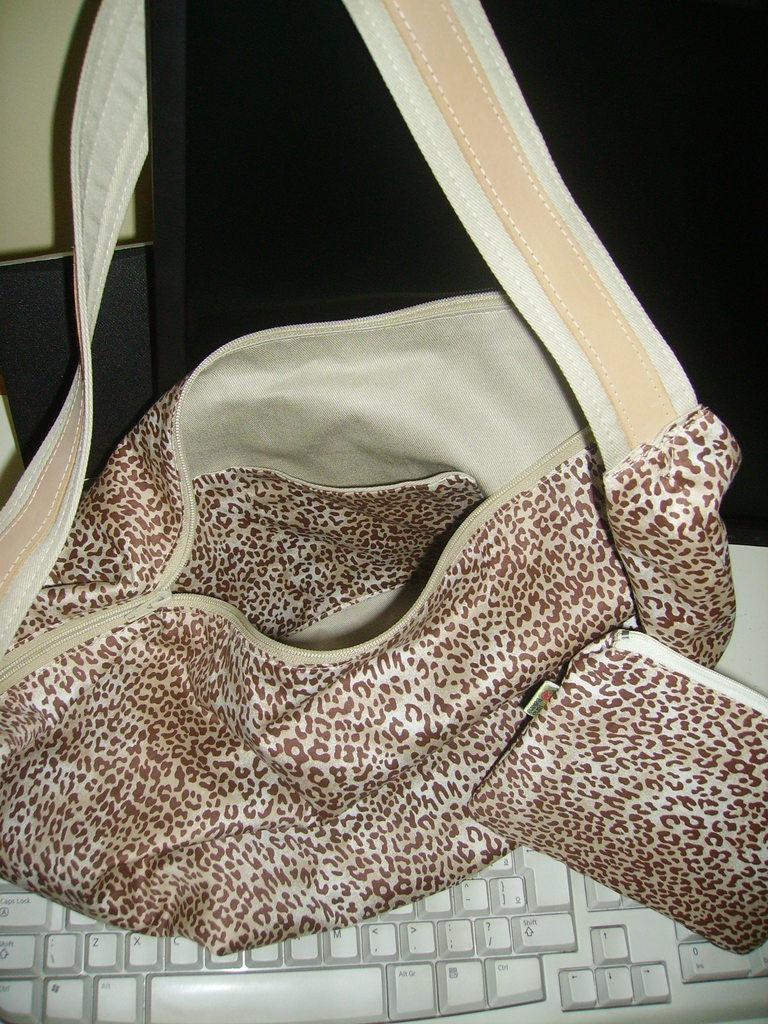What device is present in the image for typing? There is a keyboard in the image. What is the keyboard connected to in the image? There is a system (computer or laptop) in the image. What additional item can be seen in the image? There is a bag in the image. How many cows are visible in the image? There are no cows present in the image. What part of the body is the chin located on in the image? There is no chin present in the image. 